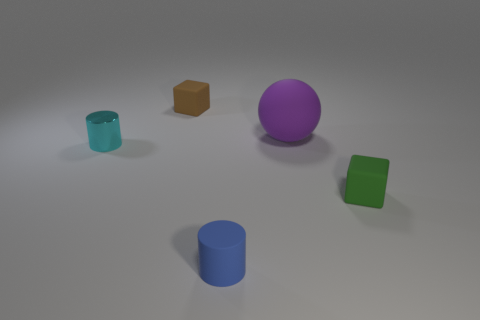Is the shape of the purple object that is to the right of the small blue matte cylinder the same as  the small cyan metal object?
Offer a very short reply. No. There is another small thing that is the same shape as the green object; what color is it?
Offer a terse response. Brown. Is there any other thing that is the same shape as the large rubber object?
Give a very brief answer. No. Is the number of large purple matte things that are to the left of the brown block the same as the number of large gray shiny balls?
Your answer should be compact. Yes. How many tiny objects are both right of the cyan metal thing and in front of the tiny brown cube?
Keep it short and to the point. 2. There is another object that is the same shape as the green thing; what is its size?
Keep it short and to the point. Small. How many small blue objects have the same material as the cyan thing?
Offer a very short reply. 0. Is the number of green matte cubes that are on the left side of the brown cube less than the number of green blocks?
Ensure brevity in your answer.  Yes. How many tiny metal things are there?
Ensure brevity in your answer.  1. Is the shape of the tiny blue matte object the same as the green rubber thing?
Your response must be concise. No. 